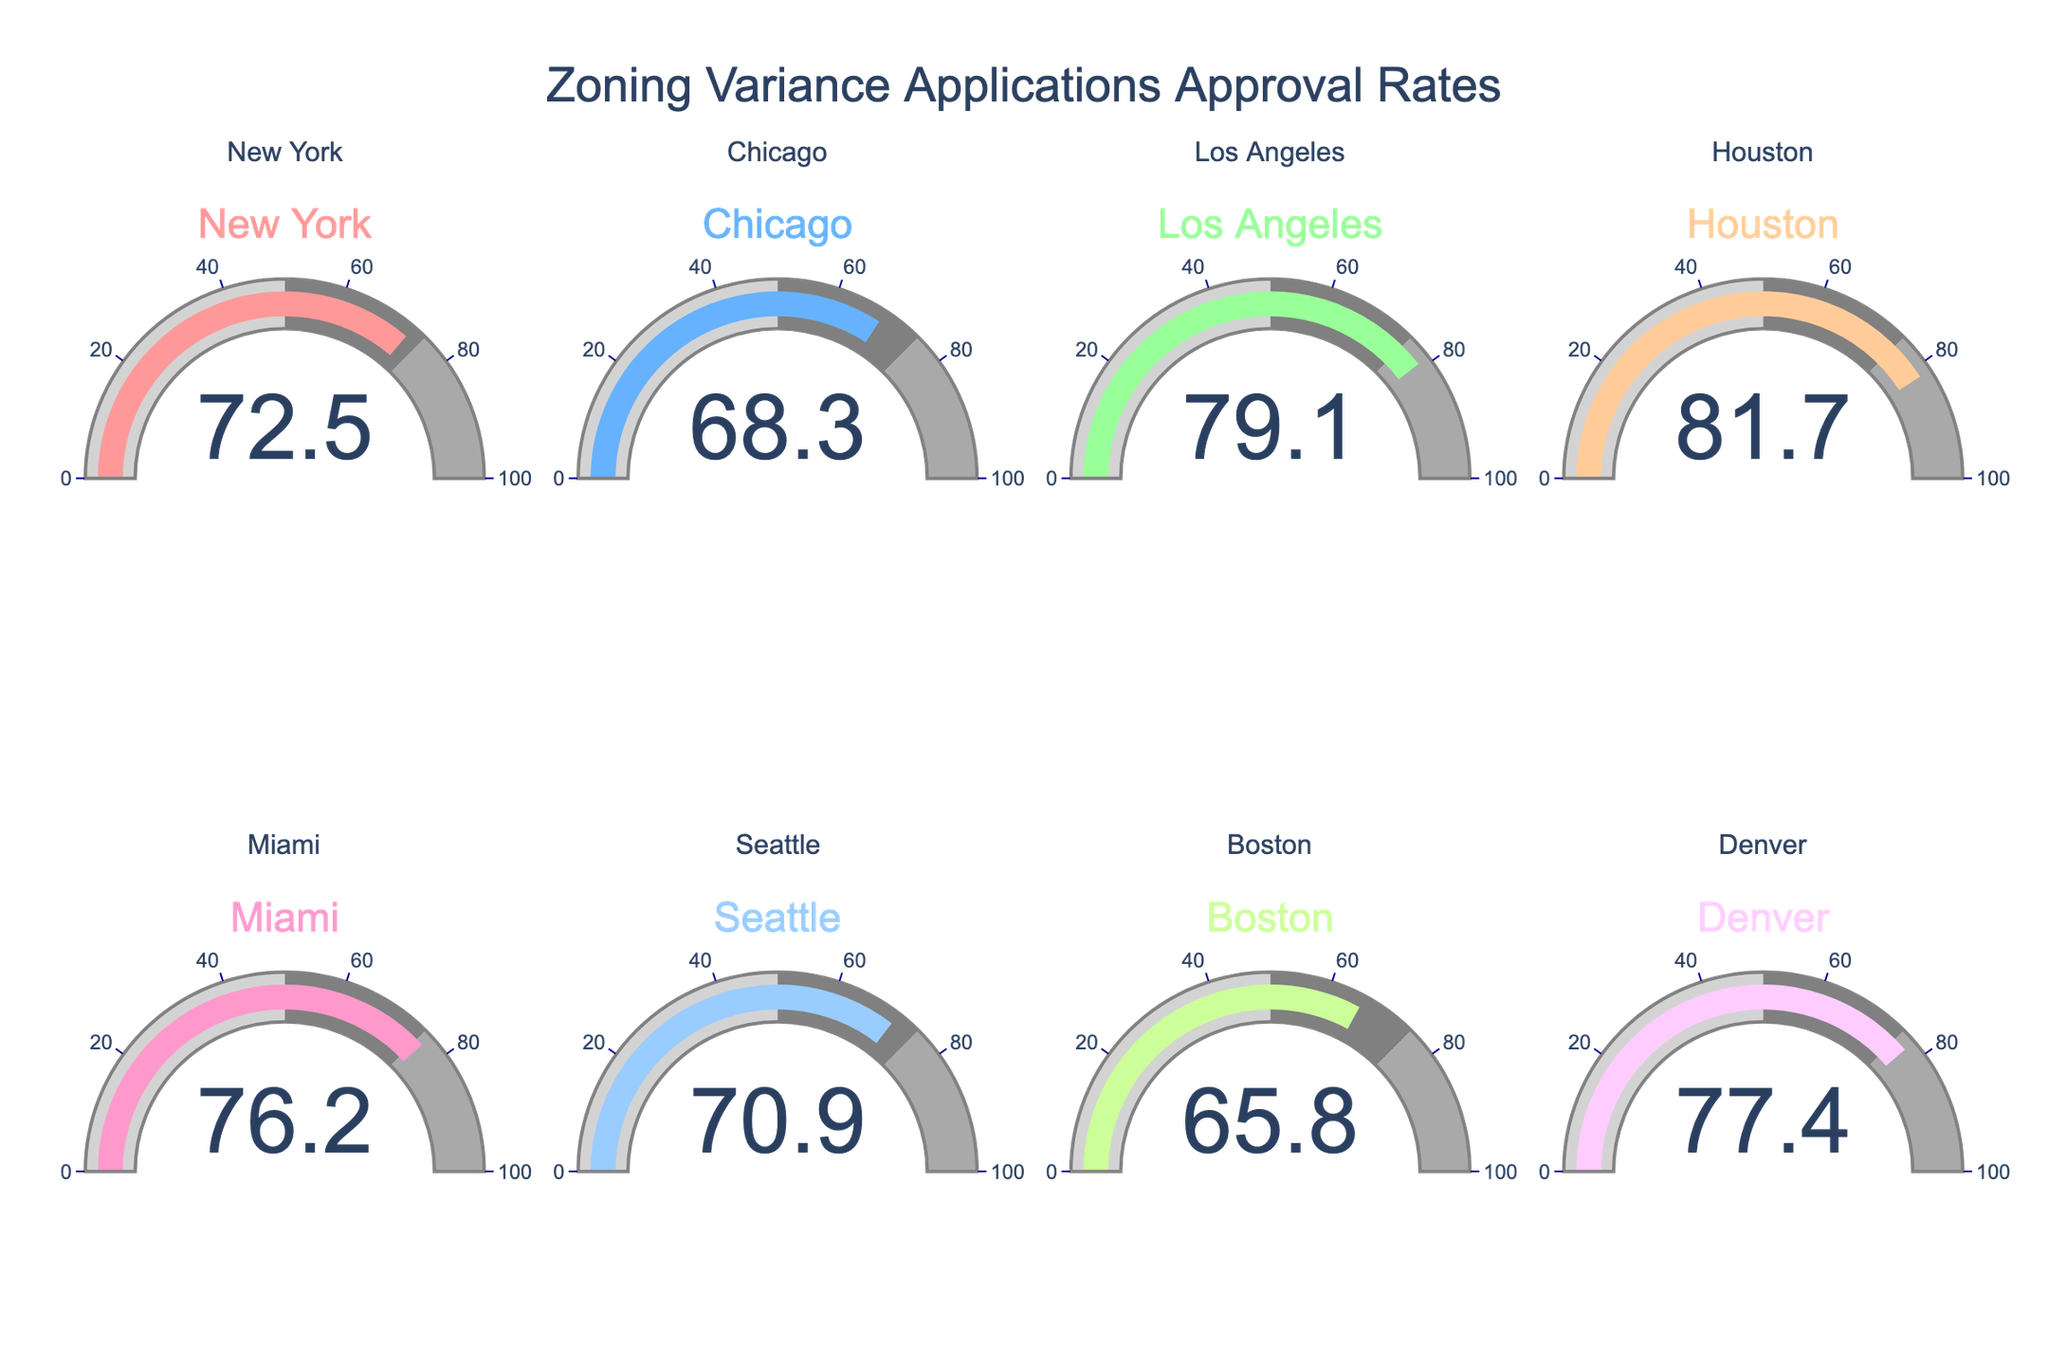What city has the highest zoning variance approval rate? The gauge chart shows each city's approval rate. Houston has the highest value at 81.7%.
Answer: Houston What city has the lowest zoning variance approval rate? The gauge chart shows each city's approval rate. Boston has the lowest value at 65.8%.
Answer: Boston How many cities have an approval rate above 75%? The gauge chart shows that Los Angeles, Houston, Miami, and Denver have approval rates above 75%.
Answer: 4 What is the average approval rate of all the cities? Sum all the approval rates and divide by the number of cities: (72.5 + 68.3 + 79.1 + 81.7 + 76.2 + 70.9 + 65.8 + 77.4) / 8 = 591.9 / 8 = 74.0
Answer: 74.0 Which city's approval rate is closest to 70%? The gauge chart shows Seattle's approval rate is 70.9%, which is the closest to 70%.
Answer: Seattle What is the combined approval rate of New York and Chicago? Add the approval rates of New York and Chicago: 72.5 + 68.3 = 140.8
Answer: 140.8 How much higher is Houston's approval rate compared to Boston's? Subtract Boston's approval rate from Houston's: 81.7 - 65.8 = 15.9
Answer: 15.9 What is the median approval rate of the cities? Order the approval rates and find the middle value: 65.8, 68.3, 70.9, 72.5, 76.2, 77.4, 79.1, 81.7. The median is the average of the 4th and 5th values: (72.5 + 76.2) / 2 = 74.35
Answer: 74.35 Which cities have approval rates between 70% and 80%? The gauge chart shows New York, Los Angeles, Miami, Seattle, and Denver fall into this range.
Answer: New York, Los Angeles, Miami, Seattle, Denver Are there more cities with approval rates above or below the average approval rate? The average approval rate is 74.0. Cities above are Los Angeles, Houston, Miami, and Denver. Cities below are New York, Chicago, Seattle, and Boston. Each has 4 cities.
Answer: Same number 